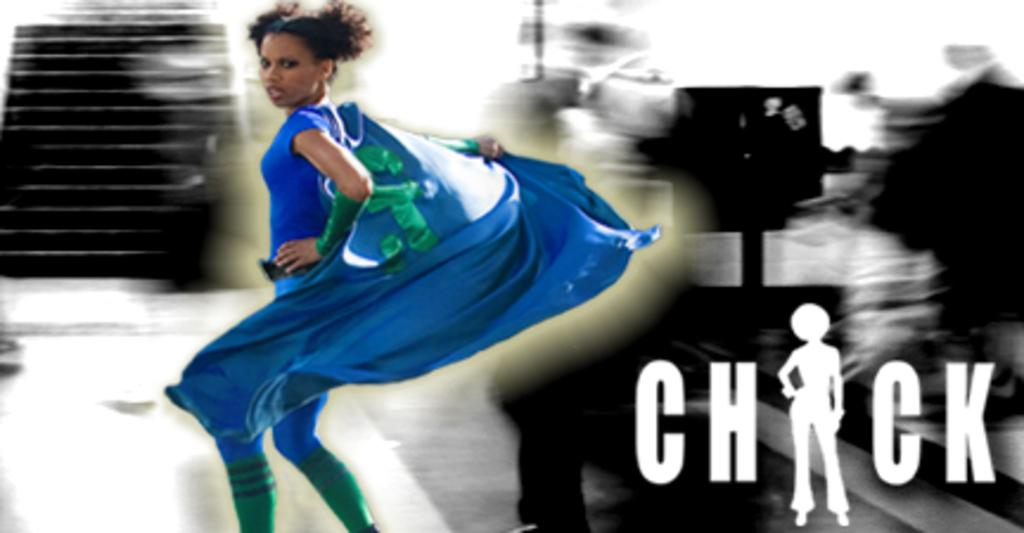Who is present in the image? There is a woman in the image. What can be seen on the right side of the image? There is text on the right side of the image. What architectural feature is on the left side of the image? There are stairs on the left side of the image. How would you describe the background of the image? The background of the image is blurred. Can you see any boats or ships in the harbor in the image? There is no harbor present in the image, so it is not possible to see any boats or ships. 